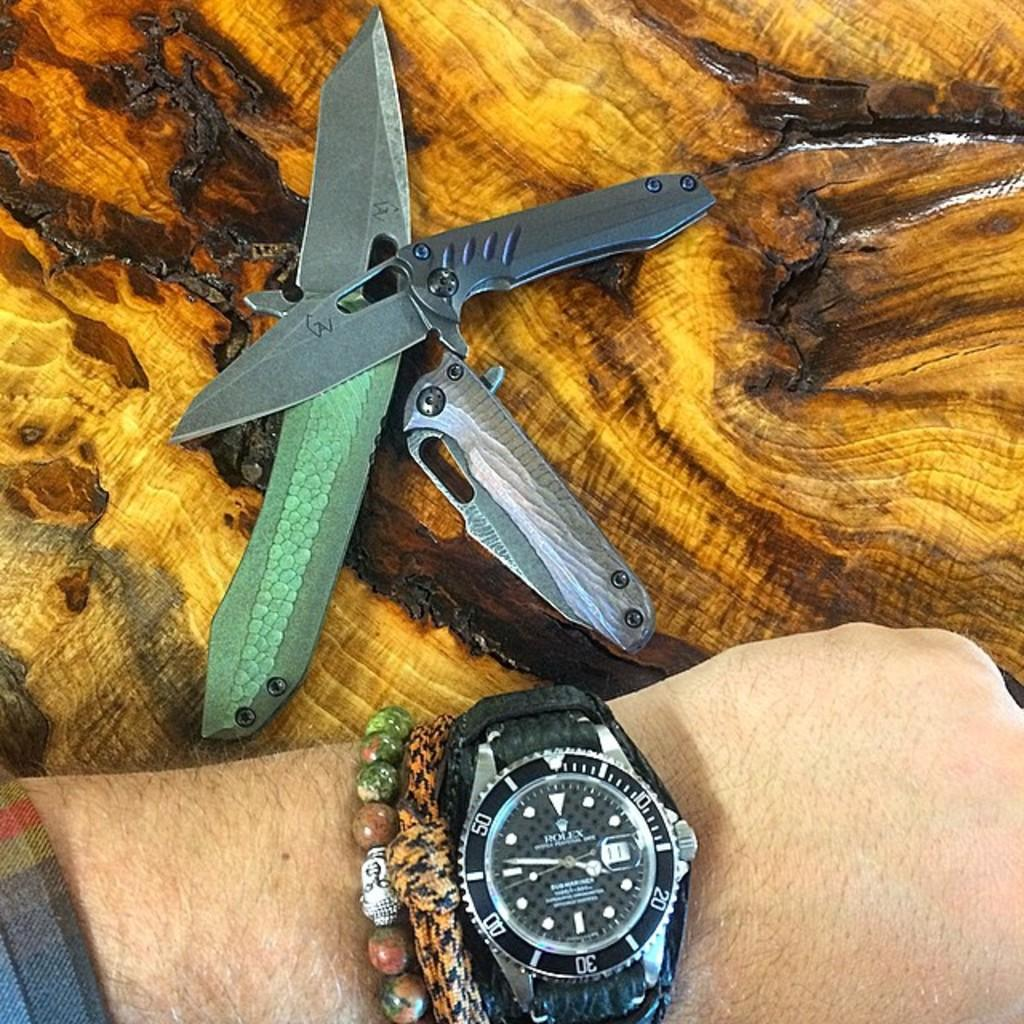Provide a one-sentence caption for the provided image. A Rolex watch has a black face and is on the wrist of a man. 